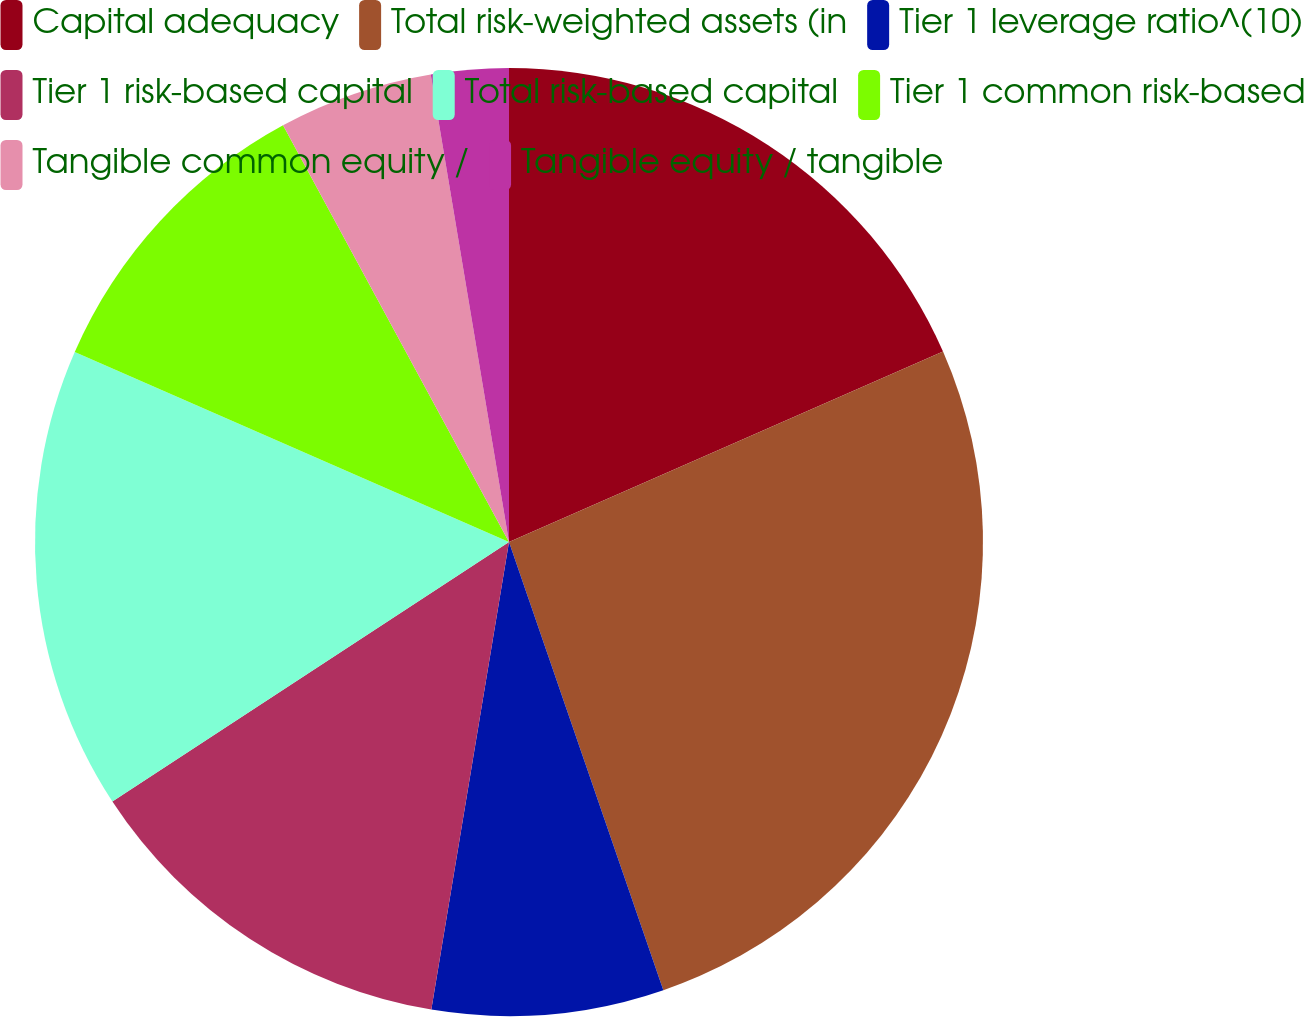<chart> <loc_0><loc_0><loc_500><loc_500><pie_chart><fcel>Capital adequacy<fcel>Total risk-weighted assets (in<fcel>Tier 1 leverage ratio^(10)<fcel>Tier 1 risk-based capital<fcel>Total risk-based capital<fcel>Tier 1 common risk-based<fcel>Tangible common equity /<fcel>Tangible equity / tangible<nl><fcel>18.42%<fcel>26.31%<fcel>7.9%<fcel>13.16%<fcel>15.79%<fcel>10.53%<fcel>5.27%<fcel>2.64%<nl></chart> 